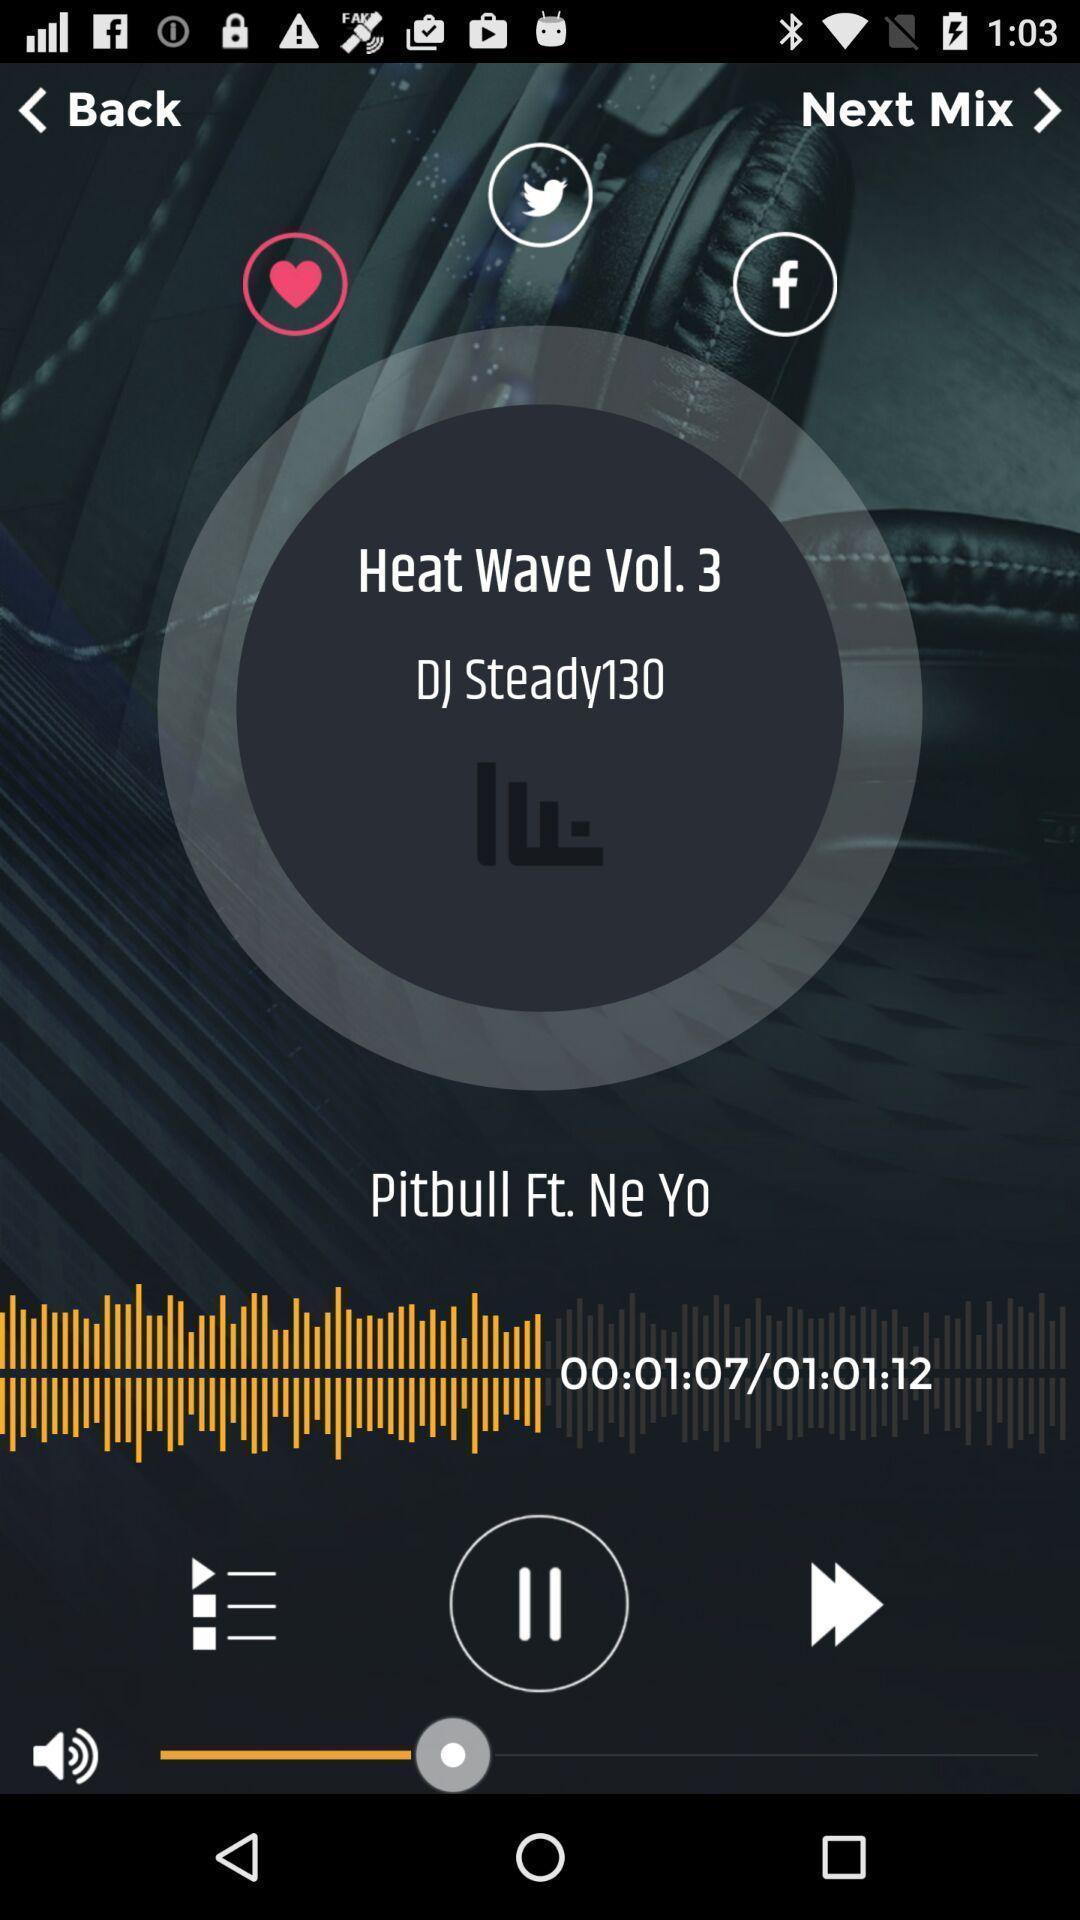Provide a detailed account of this screenshot. Screen page of a music application. 